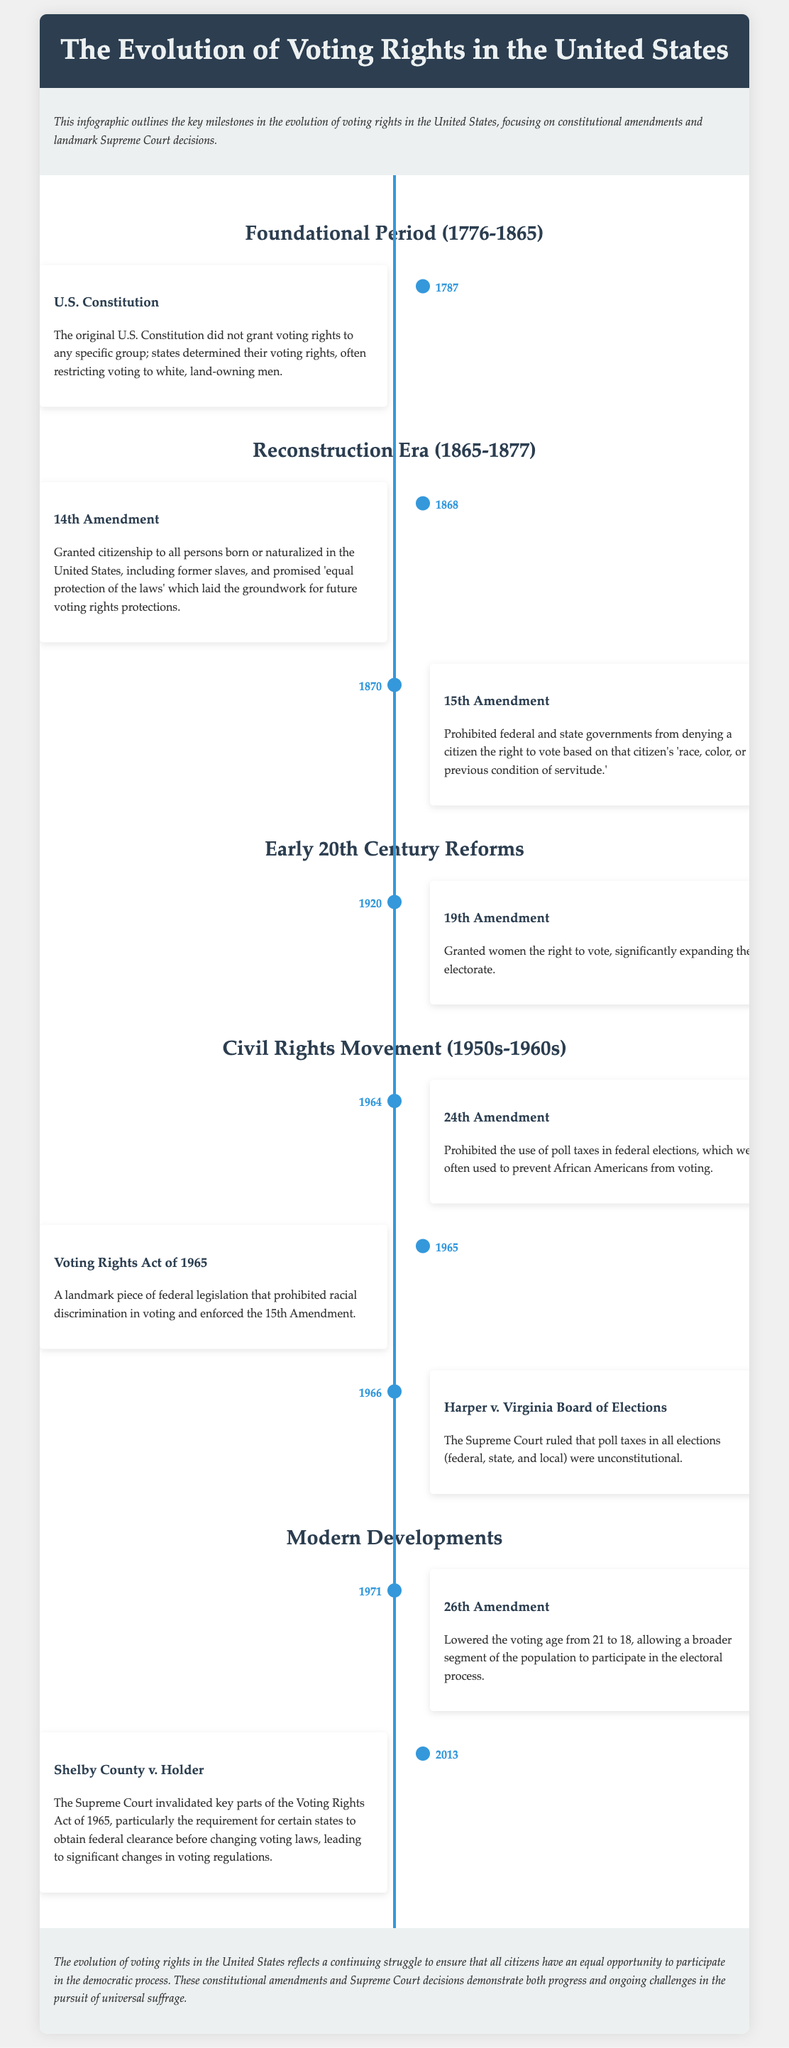What year was the 14th Amendment ratified? The timeline indicates that the 14th Amendment was ratified in 1868.
Answer: 1868 What does the 15th Amendment prohibit? The document states it prohibits denying the right to vote based on 'race, color, or previous condition of servitude.'
Answer: Race, color, or previous condition of servitude Which amendment granted women the right to vote? The 19th Amendment is mentioned as granting women the right to vote in 1920.
Answer: 19th Amendment What landmark legislation was passed in 1965? The document highlights the Voting Rights Act of 1965 as a significant law during the Civil Rights Movement.
Answer: Voting Rights Act of 1965 What legal case ruled that poll taxes were unconstitutional? According to the document, the Supreme Court case Harper v. Virginia Board of Elections ruled poll taxes unconstitutional in 1966.
Answer: Harper v. Virginia Board of Elections How many amendments specifically relate to voting rights in the timeline? The timeline lists 6 amendments relating to voting rights: 14th, 15th, 19th, 24th, and 26th Amendments.
Answer: 5 Amendments Which Supreme Court case invalidated parts of the Voting Rights Act? The timeline mentions Shelby County v. Holder as the case that invalidated key parts of the Voting Rights Act of 1965 in 2013.
Answer: Shelby County v. Holder What was significant about the 26th Amendment? The document states that the 26th Amendment lowered the voting age from 21 to 18.
Answer: Lowered voting age to 18 What phrase describes the focus of the timeline? The introduction states that the focus of the infographic is on key milestones in the evolution of voting rights in the United States.
Answer: Key milestones in the evolution of voting rights 